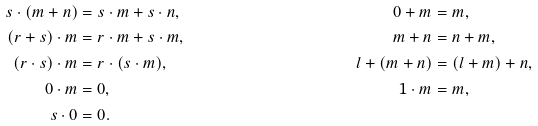<formula> <loc_0><loc_0><loc_500><loc_500>s \cdot ( m + n ) & = s \cdot m + s \cdot n , & 0 + m & = m , \\ ( r + s ) \cdot m & = r \cdot m + s \cdot m , & m + n & = n + m , \\ ( r \cdot s ) \cdot m & = r \cdot ( s \cdot m ) , & l + ( m + n ) & = ( l + m ) + n , \\ 0 \cdot m & = 0 , & 1 \cdot m & = m , \\ s \cdot 0 & = 0 .</formula> 